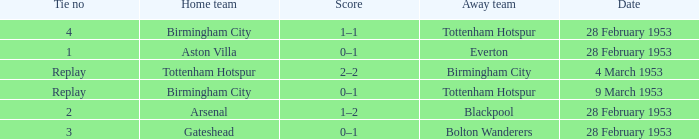Which Tie no has a Score of 0–1, and a Date of 9 march 1953? Replay. 